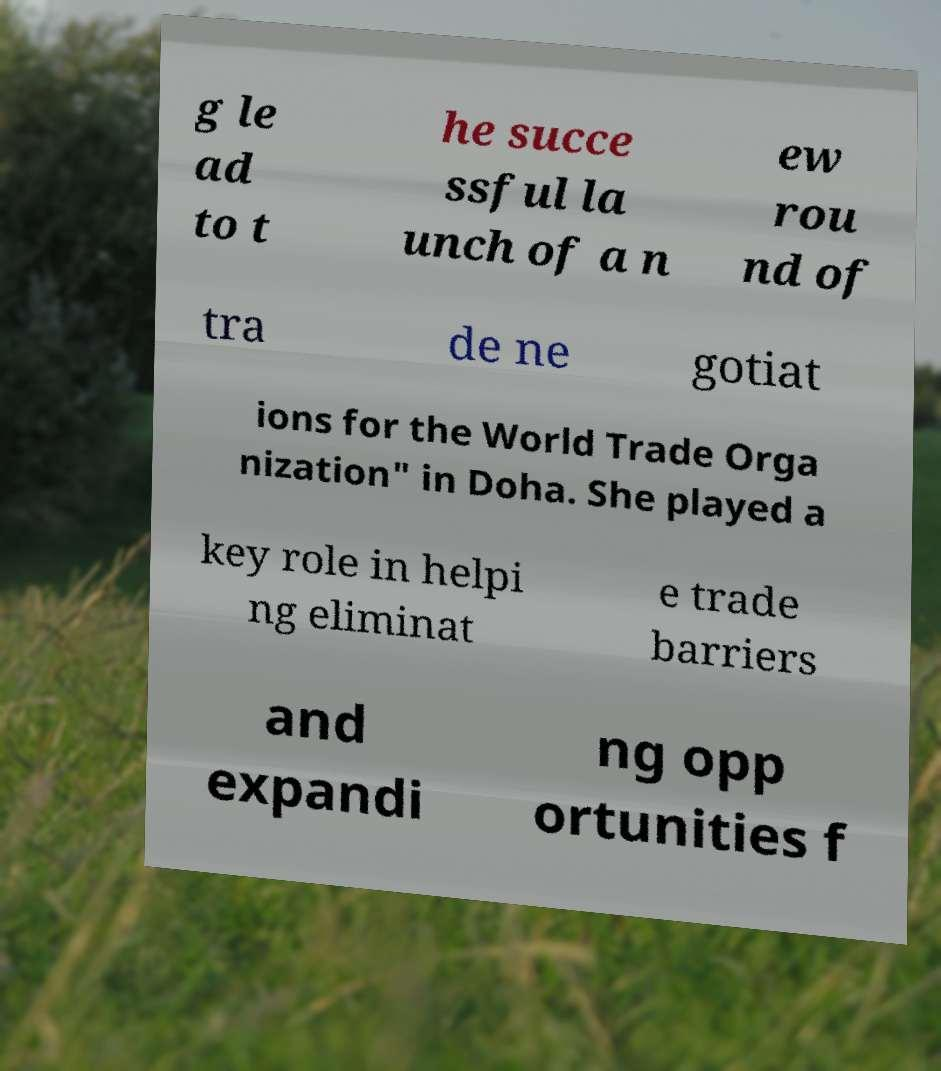Please read and relay the text visible in this image. What does it say? g le ad to t he succe ssful la unch of a n ew rou nd of tra de ne gotiat ions for the World Trade Orga nization" in Doha. She played a key role in helpi ng eliminat e trade barriers and expandi ng opp ortunities f 